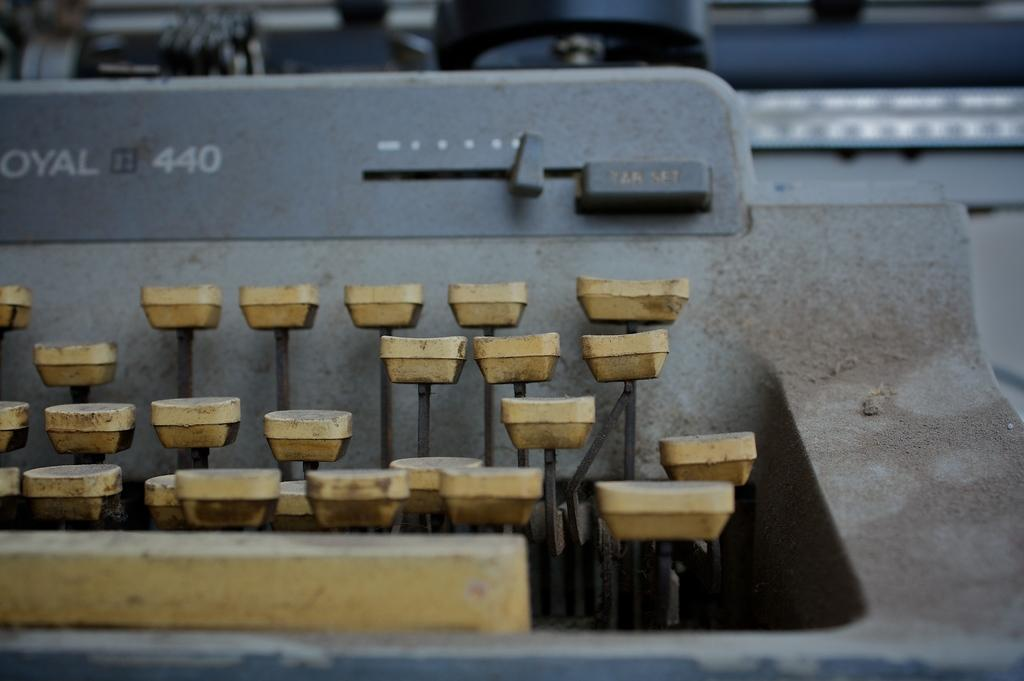Provide a one-sentence caption for the provided image. An old typewriter is a Royal 440 model and is quite dirty. 